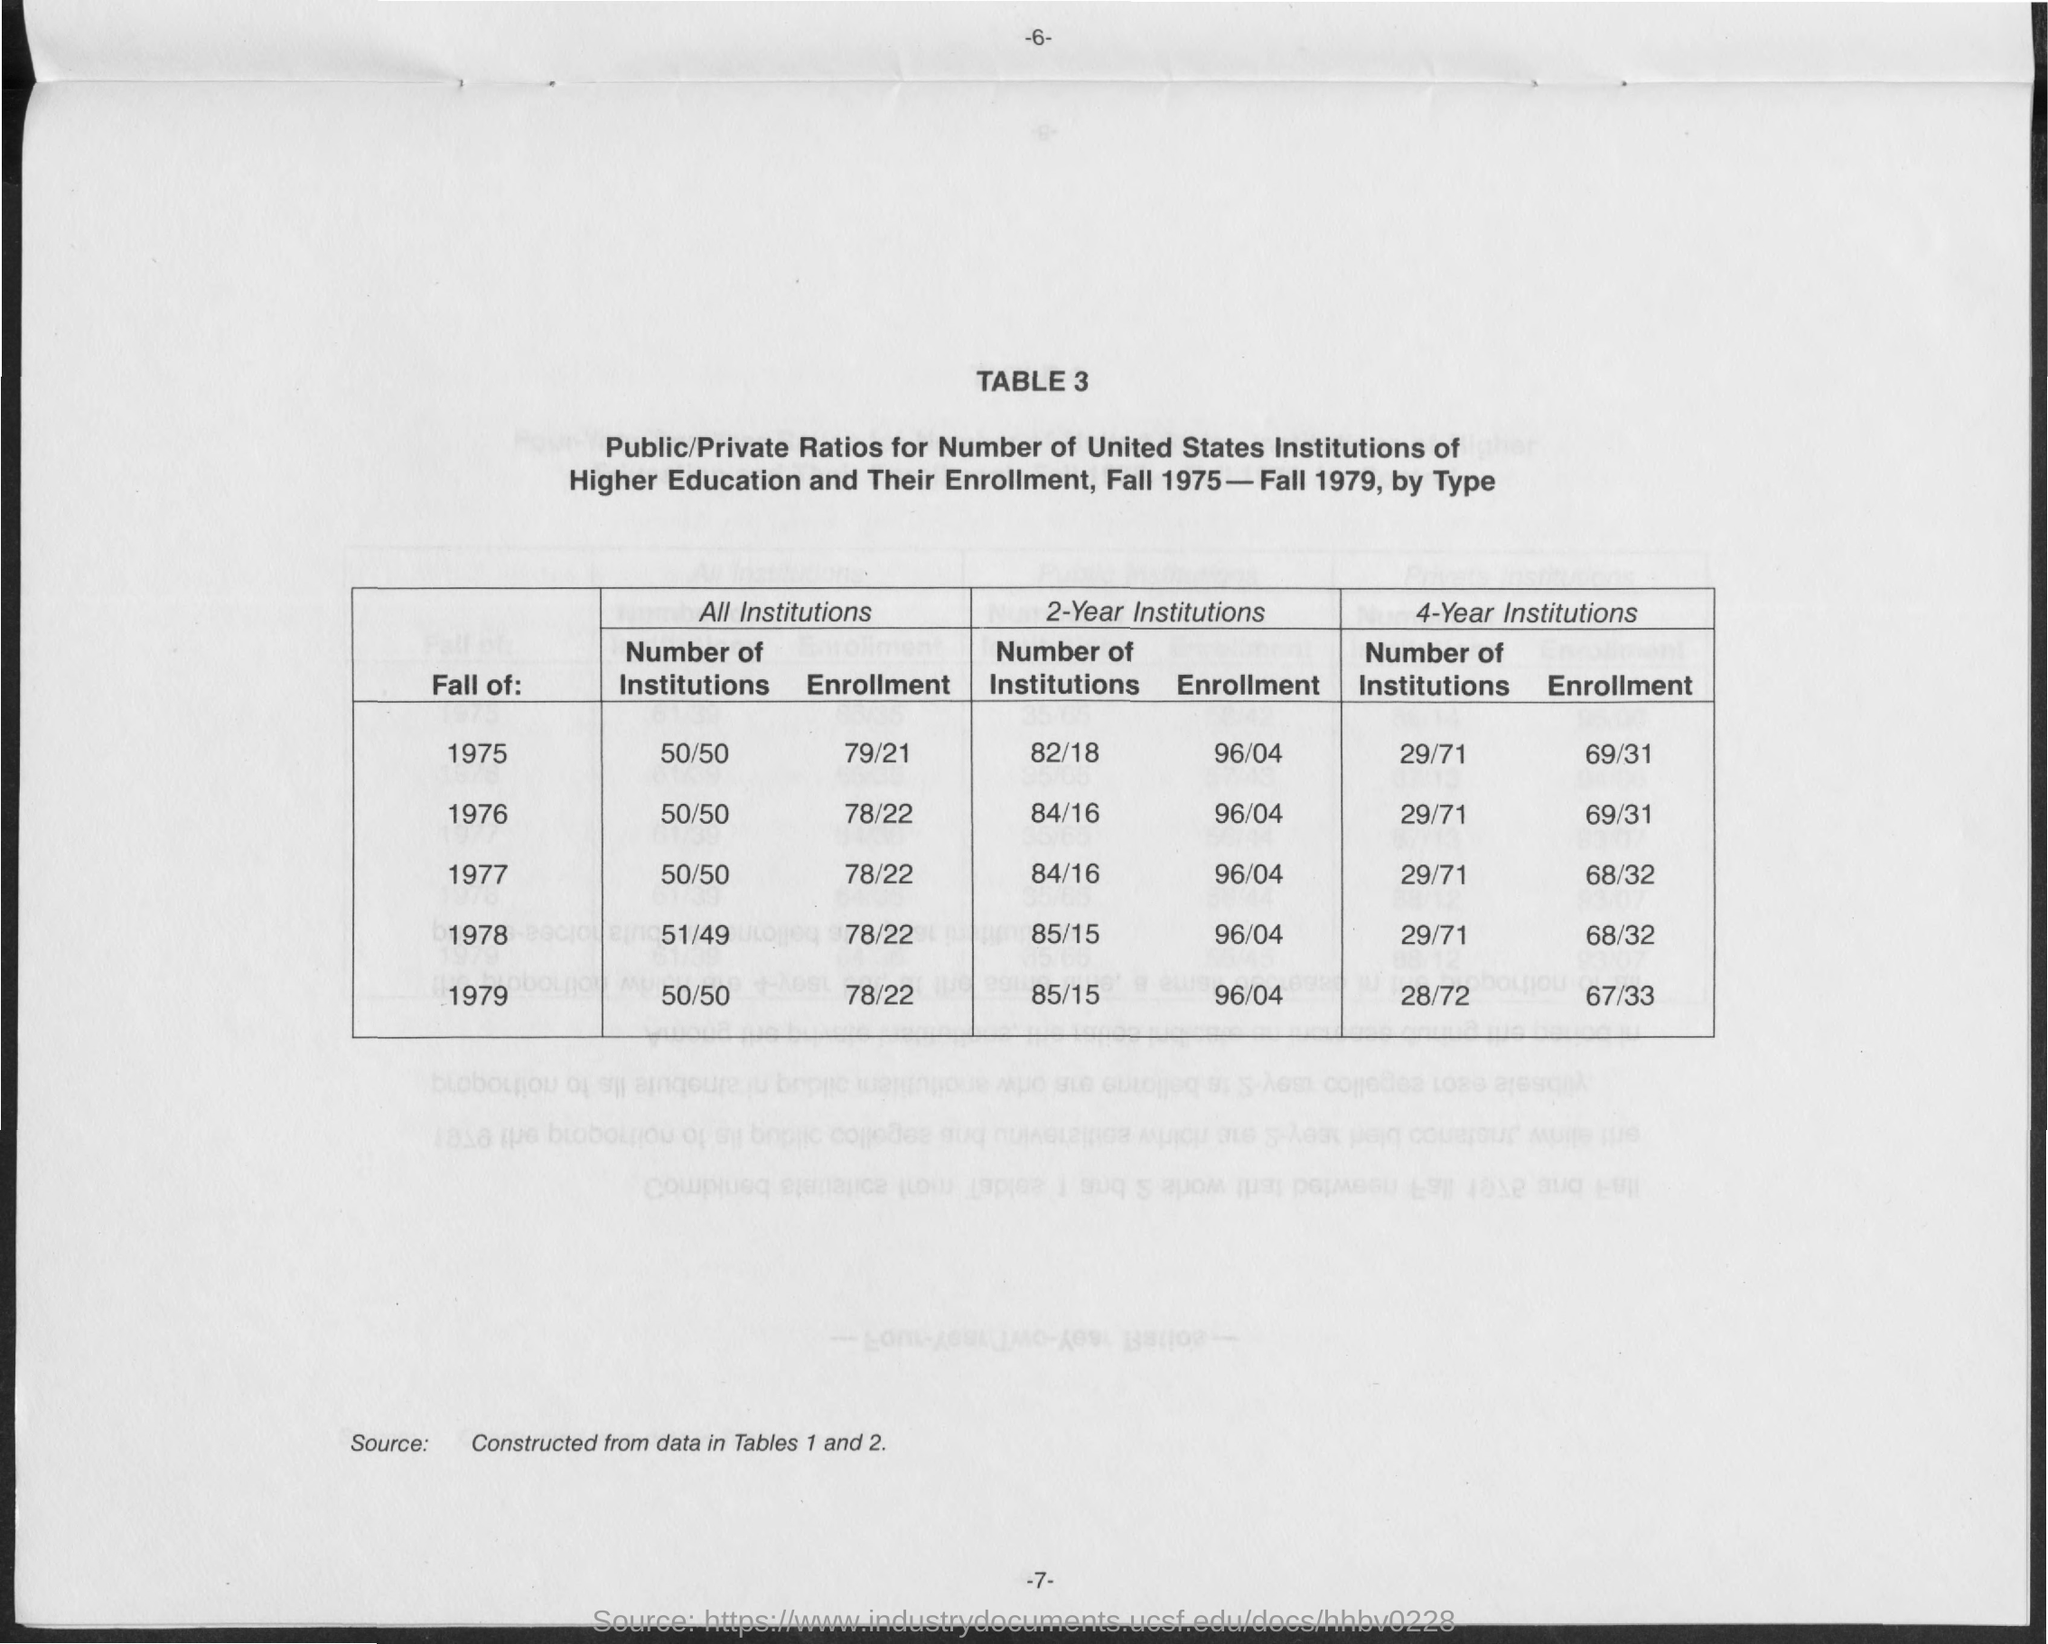Highlight a few significant elements in this photo. The value of enrollment for all institutions in the fall of 1977 was approximately 78/22. The value of enrollment for all institutions in the fall of 1978 was approximately 78/22. The value of enrollment for 2-Year institutions in the fall of 1975 was 96/04. In the fall of 1976, the enrollment at all institutions was 78/22. The enrollment for all institutions in the fall of 1975 was 79/21. 